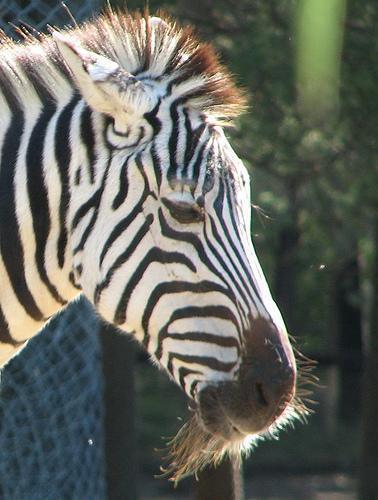How many zebras are seen?
Give a very brief answer. 1. 